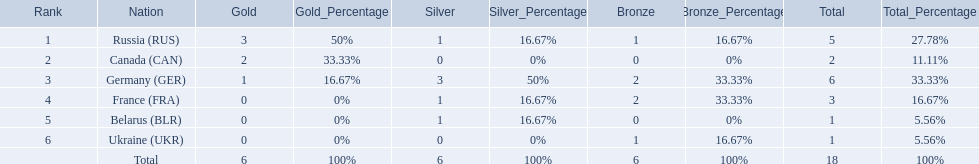Which countries received gold medals? Russia (RUS), Canada (CAN), Germany (GER). Of these countries, which did not receive a silver medal? Canada (CAN). 